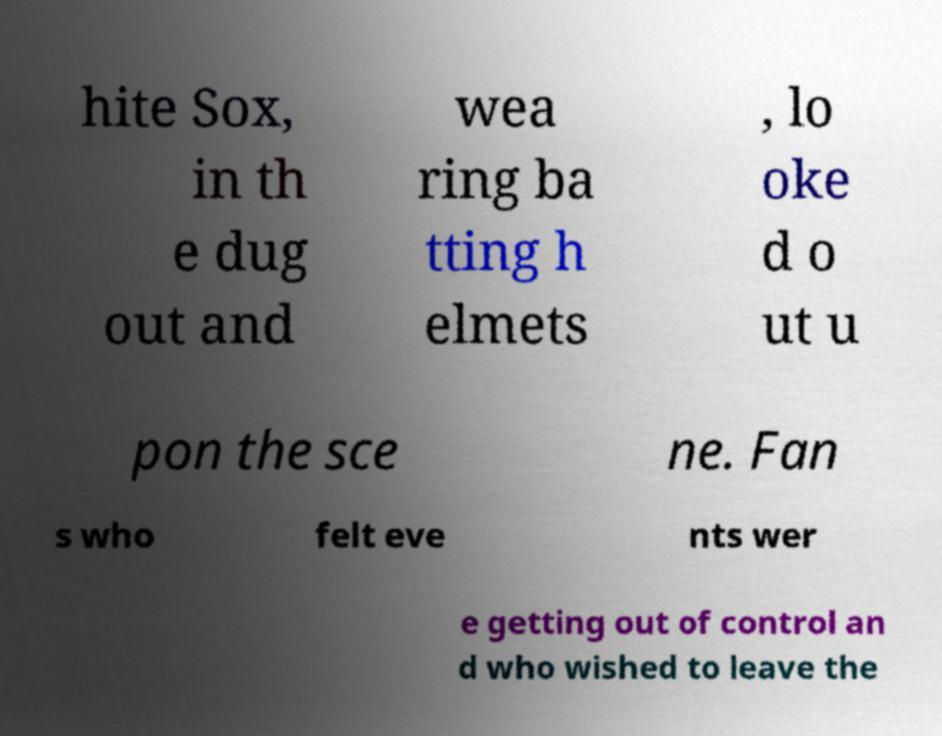Could you extract and type out the text from this image? hite Sox, in th e dug out and wea ring ba tting h elmets , lo oke d o ut u pon the sce ne. Fan s who felt eve nts wer e getting out of control an d who wished to leave the 